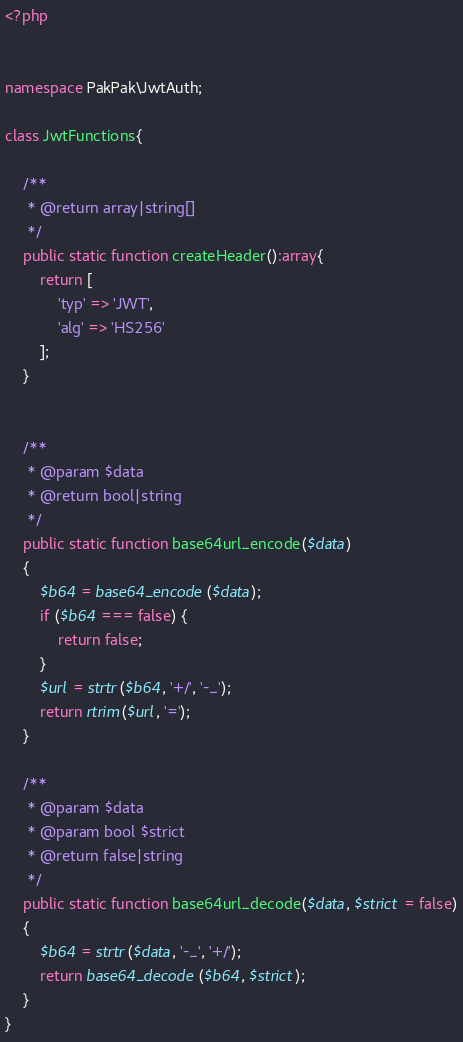Convert code to text. <code><loc_0><loc_0><loc_500><loc_500><_PHP_><?php


namespace PakPak\JwtAuth;

class JwtFunctions{

    /**
     * @return array|string[]
     */
    public static function createHeader():array{
        return [
            'typ' => 'JWT',
            'alg' => 'HS256'
        ];
    }


    /**
     * @param $data
     * @return bool|string
     */
    public static function base64url_encode($data)
    {
        $b64 = base64_encode($data);
        if ($b64 === false) {
            return false;
        }
        $url = strtr($b64, '+/', '-_');
        return rtrim($url, '=');
    }

    /**
     * @param $data
     * @param bool $strict
     * @return false|string
     */
    public static function base64url_decode($data, $strict = false)
    {
        $b64 = strtr($data, '-_', '+/');
        return base64_decode($b64, $strict);
    }
}
</code> 